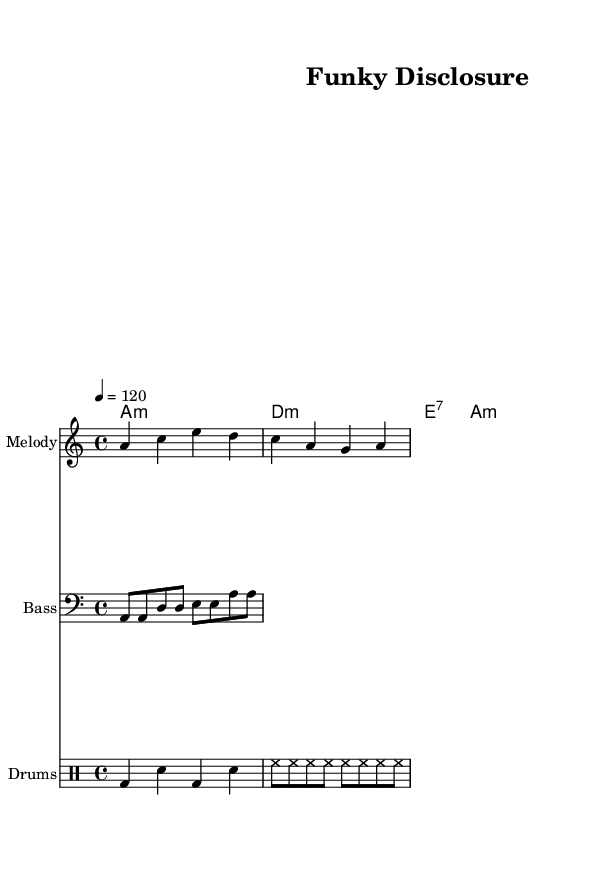What is the time signature of this music? The time signature is indicated at the beginning of the staff. It appears as "4/4," meaning there are four beats in each measure and the quarter note gets one beat.
Answer: 4/4 What key is the music in? The key signature can be found at the beginning of the staff, which shows an "A minor" key sign. This means the piece is centered around the A minor scale.
Answer: A minor What is the tempo marking in this piece? The tempo is provided at the beginning of the score, written as "4 = 120," which means the metronome is set to 120 beats per minute.
Answer: 120 How many measures are in the melody section? By counting the measures notated in the melody staff, there are 2 complete measures present, representing the melody.
Answer: 2 What type of chords are used in the harmonies? The harmonies indicate chord types present throughout the piece by listing them as "a1:m," "d:m," "e:7," and "a:m," showing the use of minor and dominant chords.
Answer: Minor and dominant What is the main theme expressed in the lyrics? The lyrics express themes of truth and discovery through the line "Digging deep, uncovering lies," suggesting a quest for authenticity and honesty.
Answer: Uncovering lies What rhythmic element characterizes the drum section? The drum patterns include a bass drum, snare, and hi-hat, showing a typical disco rhythm that emphasizes steady beats and syncopation.
Answer: Disco rhythm 